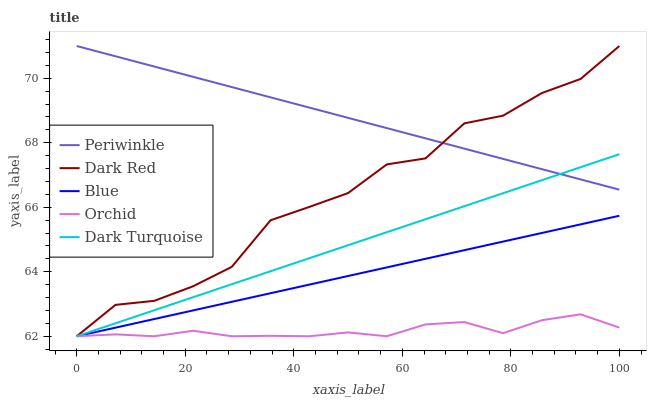Does Orchid have the minimum area under the curve?
Answer yes or no. Yes. Does Periwinkle have the maximum area under the curve?
Answer yes or no. Yes. Does Dark Red have the minimum area under the curve?
Answer yes or no. No. Does Dark Red have the maximum area under the curve?
Answer yes or no. No. Is Blue the smoothest?
Answer yes or no. Yes. Is Dark Red the roughest?
Answer yes or no. Yes. Is Periwinkle the smoothest?
Answer yes or no. No. Is Periwinkle the roughest?
Answer yes or no. No. Does Blue have the lowest value?
Answer yes or no. Yes. Does Periwinkle have the lowest value?
Answer yes or no. No. Does Periwinkle have the highest value?
Answer yes or no. Yes. Does Dark Turquoise have the highest value?
Answer yes or no. No. Is Blue less than Periwinkle?
Answer yes or no. Yes. Is Periwinkle greater than Orchid?
Answer yes or no. Yes. Does Dark Turquoise intersect Periwinkle?
Answer yes or no. Yes. Is Dark Turquoise less than Periwinkle?
Answer yes or no. No. Is Dark Turquoise greater than Periwinkle?
Answer yes or no. No. Does Blue intersect Periwinkle?
Answer yes or no. No. 